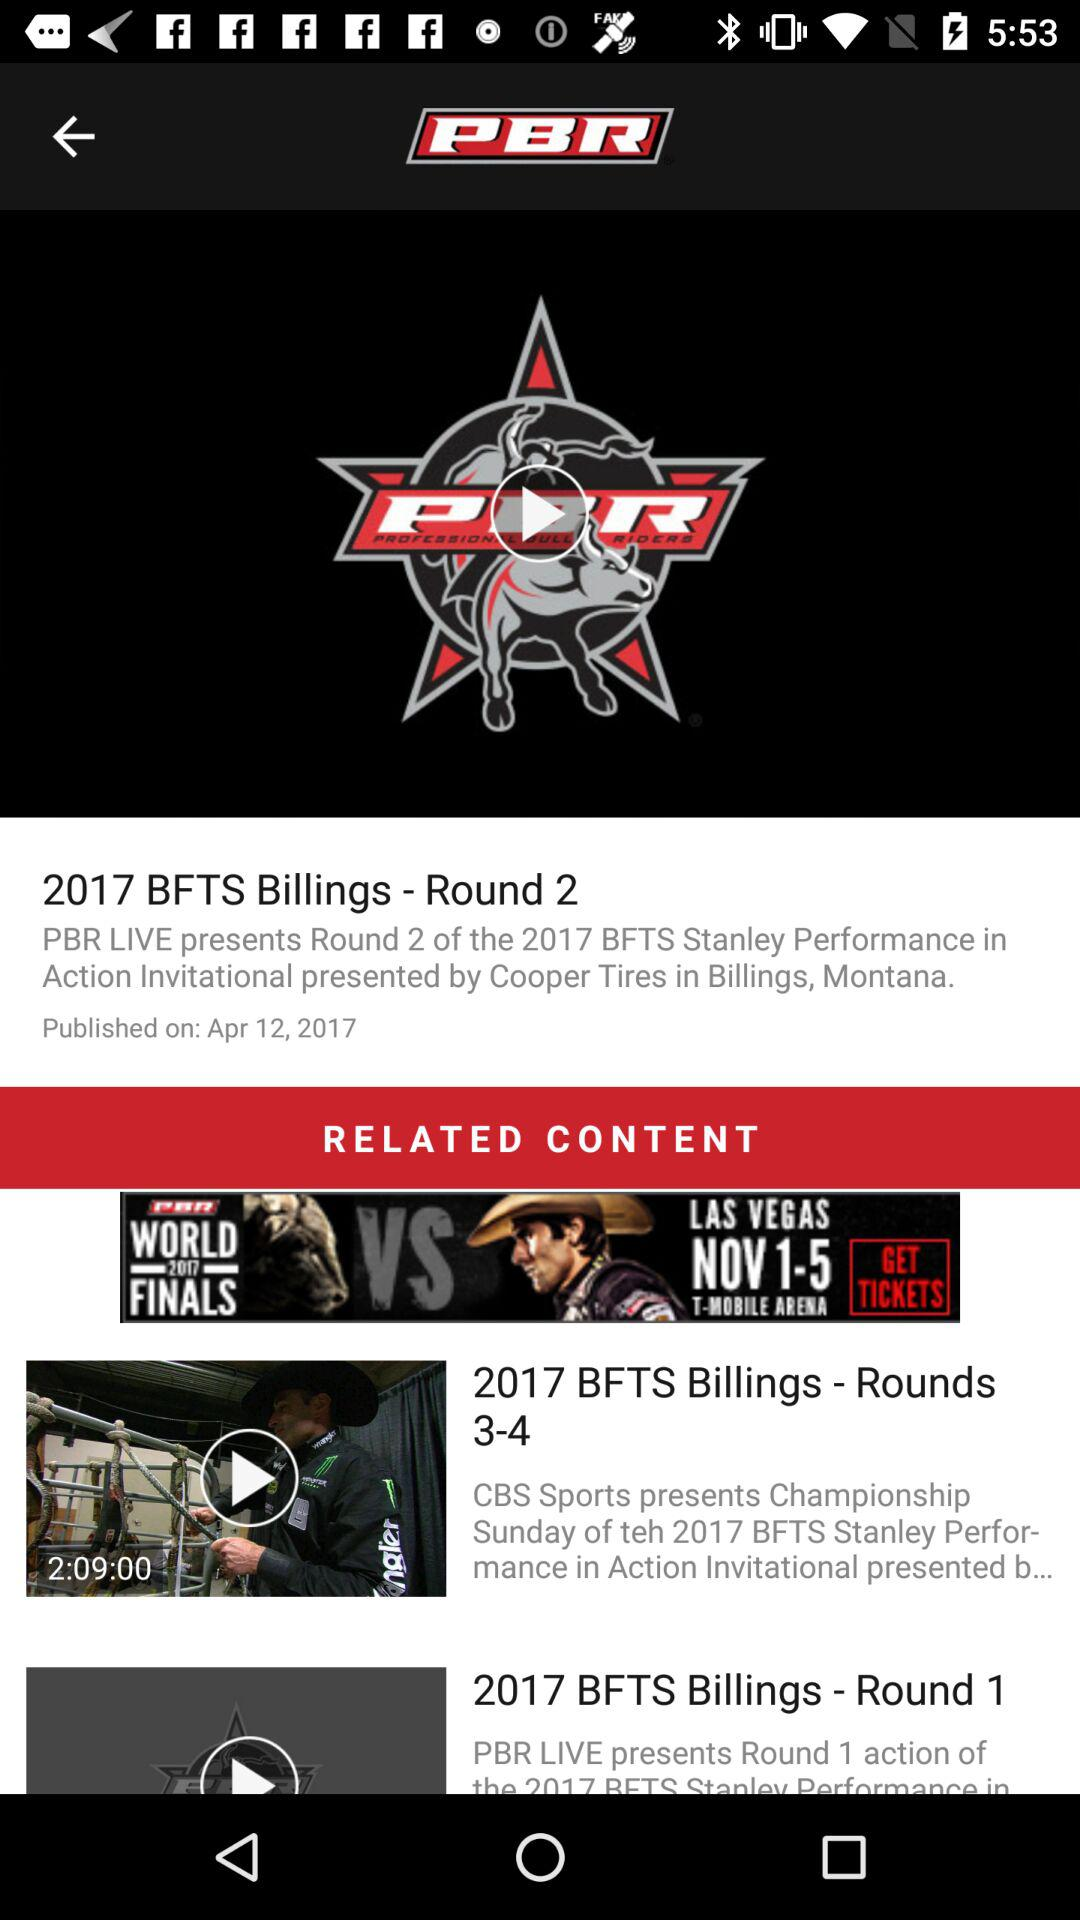What is the published date of the 2017 BFTS Billings - Round 2? The published date is April 12, 2017. 